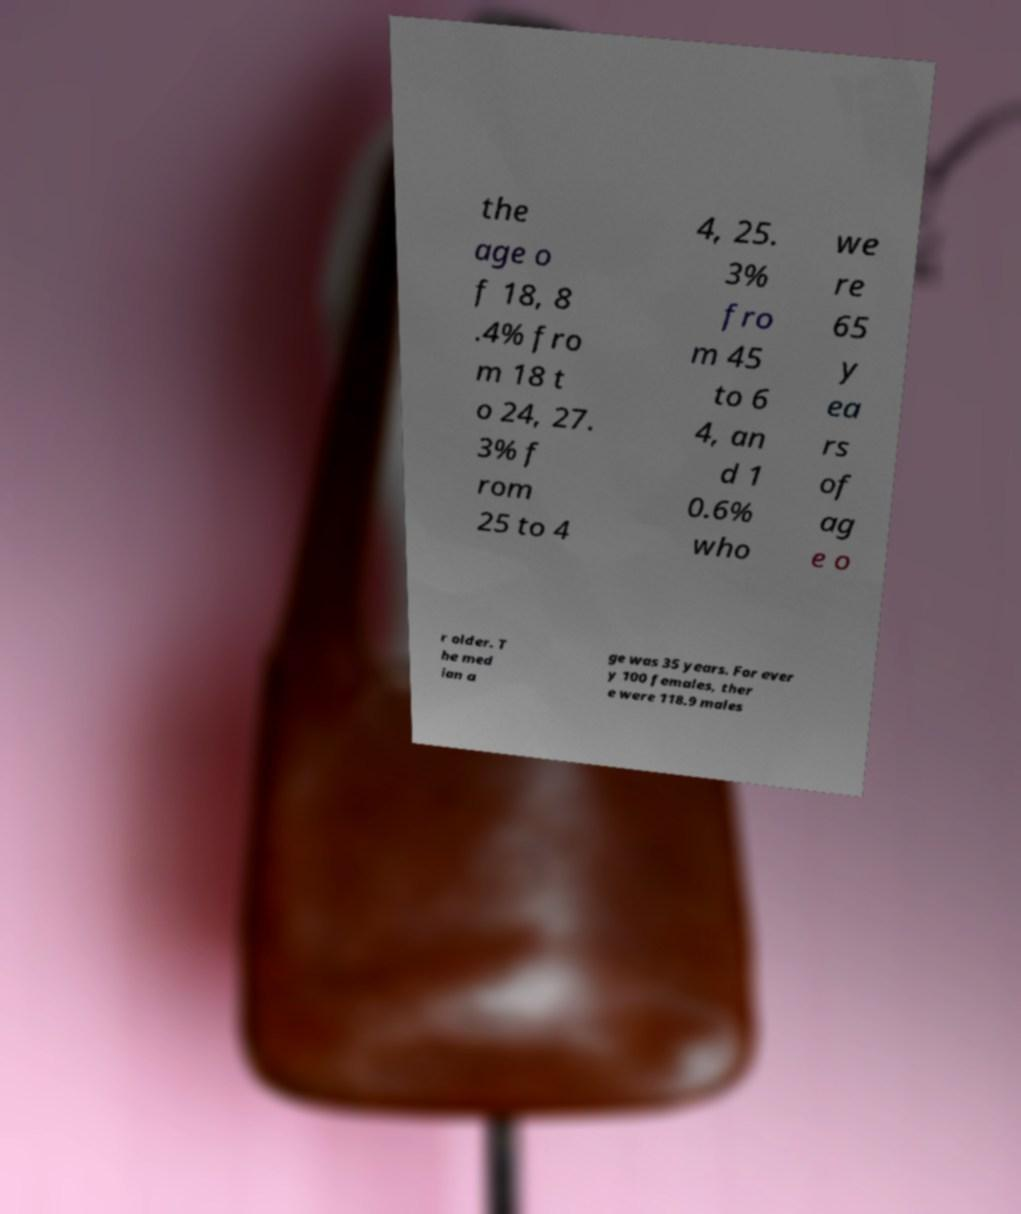There's text embedded in this image that I need extracted. Can you transcribe it verbatim? the age o f 18, 8 .4% fro m 18 t o 24, 27. 3% f rom 25 to 4 4, 25. 3% fro m 45 to 6 4, an d 1 0.6% who we re 65 y ea rs of ag e o r older. T he med ian a ge was 35 years. For ever y 100 females, ther e were 118.9 males 